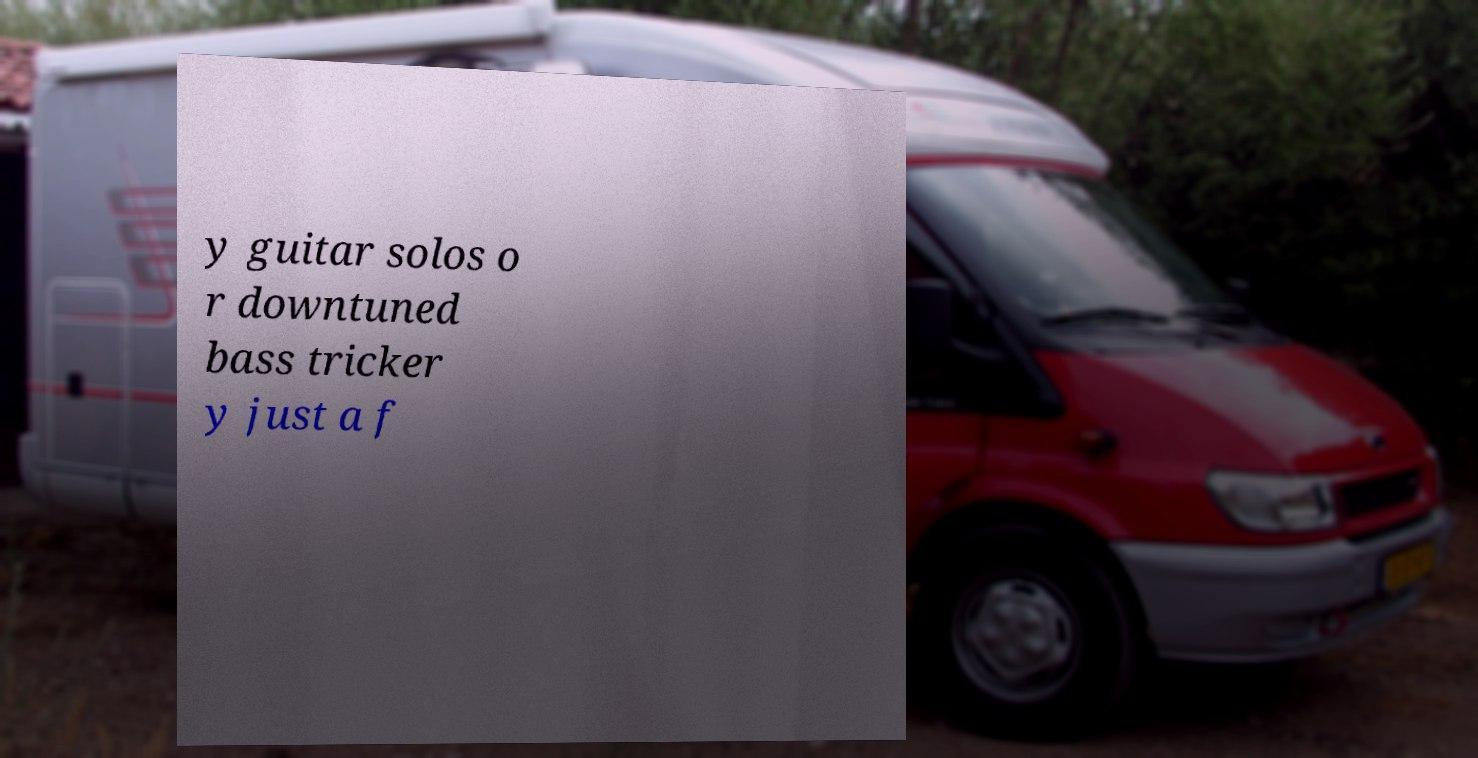Could you extract and type out the text from this image? y guitar solos o r downtuned bass tricker y just a f 